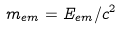Convert formula to latex. <formula><loc_0><loc_0><loc_500><loc_500>m _ { e m } = E _ { e m } / c ^ { 2 }</formula> 